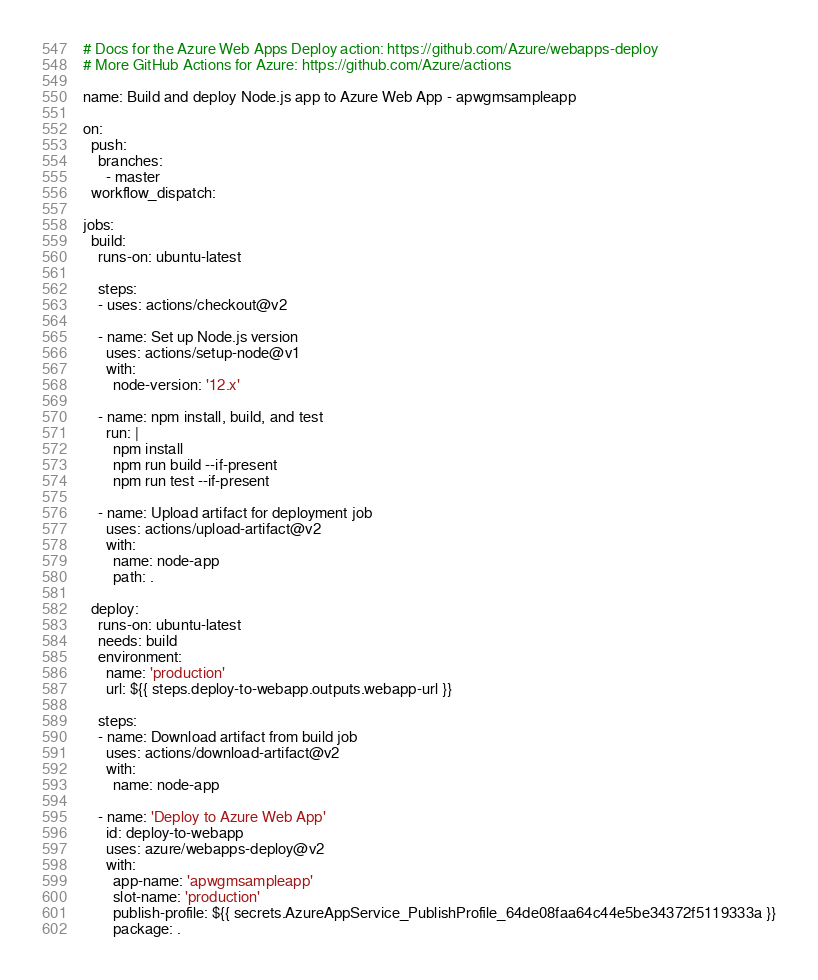<code> <loc_0><loc_0><loc_500><loc_500><_YAML_># Docs for the Azure Web Apps Deploy action: https://github.com/Azure/webapps-deploy
# More GitHub Actions for Azure: https://github.com/Azure/actions

name: Build and deploy Node.js app to Azure Web App - apwgmsampleapp

on:
  push:
    branches:
      - master
  workflow_dispatch:

jobs:
  build:
    runs-on: ubuntu-latest

    steps:
    - uses: actions/checkout@v2

    - name: Set up Node.js version
      uses: actions/setup-node@v1
      with:
        node-version: '12.x'

    - name: npm install, build, and test
      run: |
        npm install
        npm run build --if-present
        npm run test --if-present

    - name: Upload artifact for deployment job
      uses: actions/upload-artifact@v2
      with:
        name: node-app
        path: .

  deploy:
    runs-on: ubuntu-latest
    needs: build
    environment:
      name: 'production'
      url: ${{ steps.deploy-to-webapp.outputs.webapp-url }}

    steps:
    - name: Download artifact from build job
      uses: actions/download-artifact@v2
      with:
        name: node-app

    - name: 'Deploy to Azure Web App'
      id: deploy-to-webapp
      uses: azure/webapps-deploy@v2
      with:
        app-name: 'apwgmsampleapp'
        slot-name: 'production'
        publish-profile: ${{ secrets.AzureAppService_PublishProfile_64de08faa64c44e5be34372f5119333a }}
        package: .</code> 